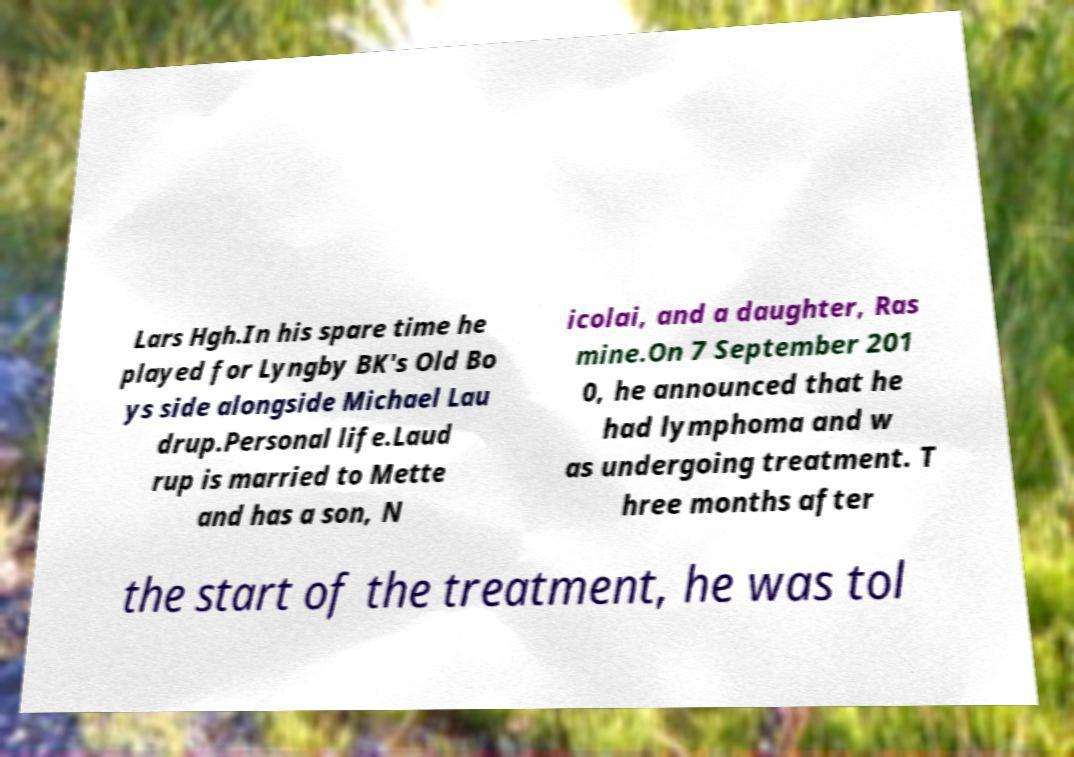There's text embedded in this image that I need extracted. Can you transcribe it verbatim? Lars Hgh.In his spare time he played for Lyngby BK's Old Bo ys side alongside Michael Lau drup.Personal life.Laud rup is married to Mette and has a son, N icolai, and a daughter, Ras mine.On 7 September 201 0, he announced that he had lymphoma and w as undergoing treatment. T hree months after the start of the treatment, he was tol 